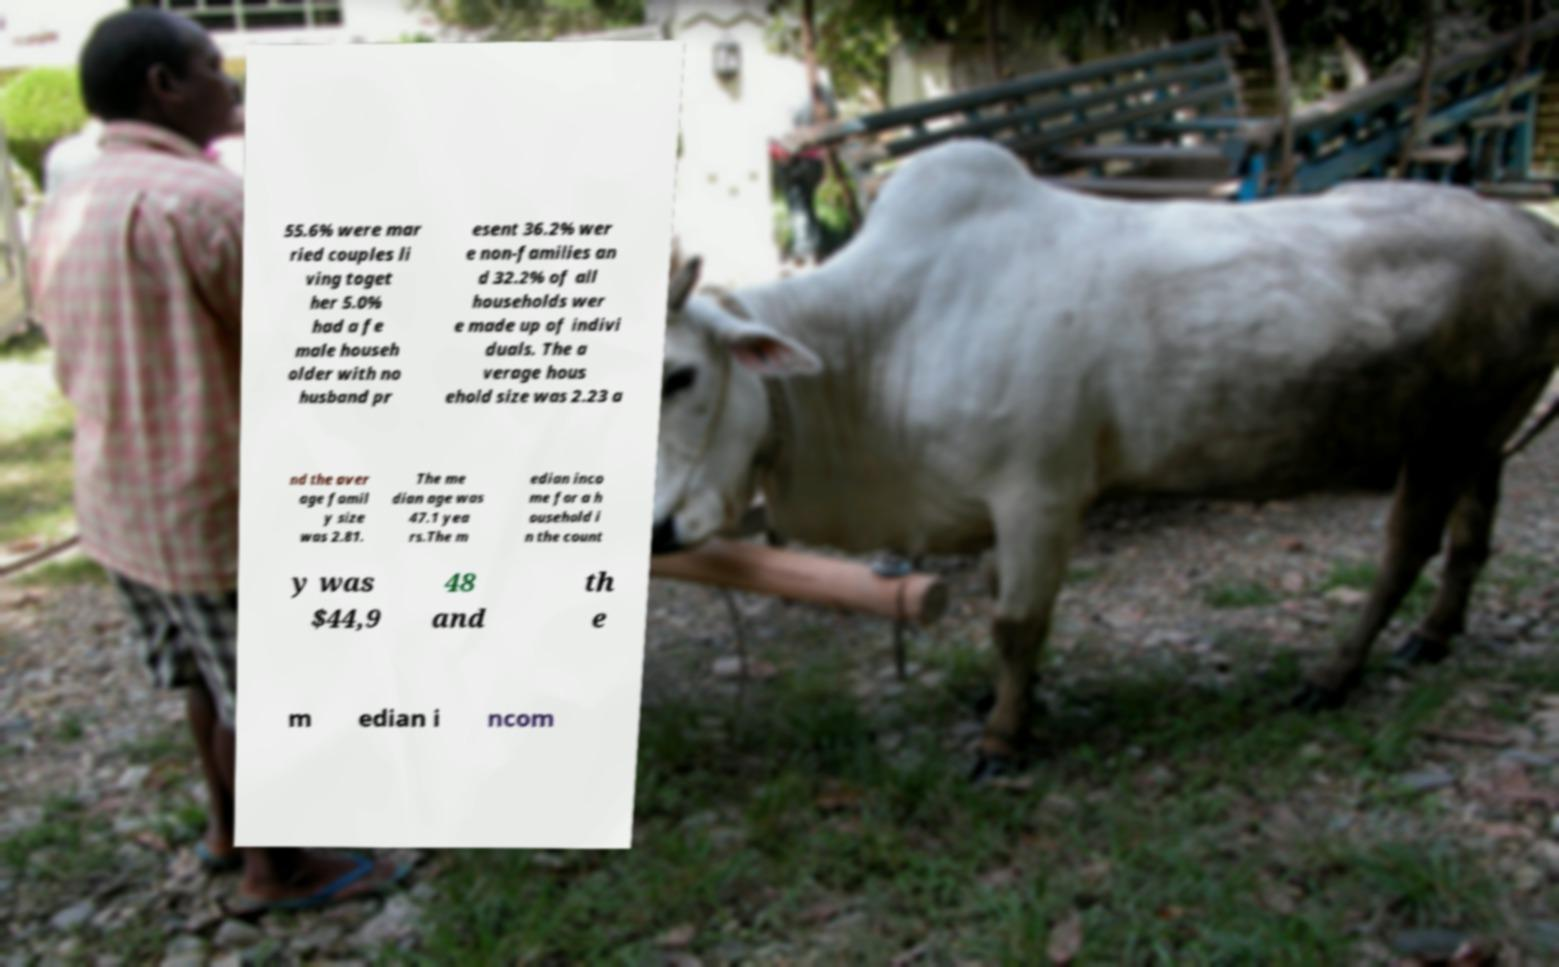Can you read and provide the text displayed in the image?This photo seems to have some interesting text. Can you extract and type it out for me? 55.6% were mar ried couples li ving toget her 5.0% had a fe male househ older with no husband pr esent 36.2% wer e non-families an d 32.2% of all households wer e made up of indivi duals. The a verage hous ehold size was 2.23 a nd the aver age famil y size was 2.81. The me dian age was 47.1 yea rs.The m edian inco me for a h ousehold i n the count y was $44,9 48 and th e m edian i ncom 